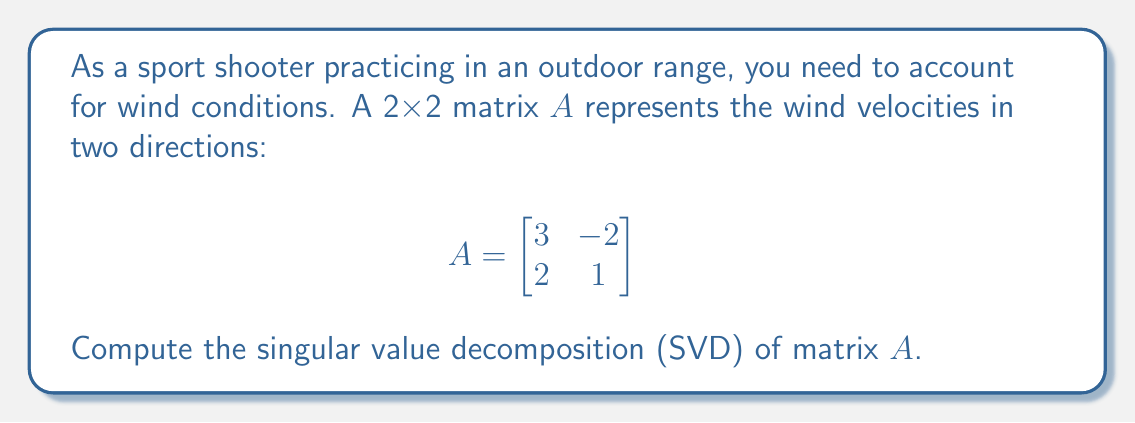Could you help me with this problem? To find the singular value decomposition of matrix $A$, we need to find matrices $U$, $\Sigma$, and $V^T$ such that $A = U\Sigma V^T$. Let's follow these steps:

1) First, calculate $A^TA$:
   $$A^TA = \begin{bmatrix}
   3 & 2 \\
   -2 & 1
   \end{bmatrix} \begin{bmatrix}
   3 & -2 \\
   2 & 1
   \end{bmatrix} = \begin{bmatrix}
   13 & -4 \\
   -4 & 5
   \end{bmatrix}$$

2) Find the eigenvalues of $A^TA$:
   $det(A^TA - \lambda I) = \begin{vmatrix}
   13-\lambda & -4 \\
   -4 & 5-\lambda
   \end{vmatrix} = (13-\lambda)(5-\lambda) - 16 = \lambda^2 - 18\lambda + 49 = 0$
   
   Solving this quadratic equation: $\lambda_1 = 16$ and $\lambda_2 = 2$

3) The singular values are the square roots of these eigenvalues:
   $\sigma_1 = \sqrt{16} = 4$ and $\sigma_2 = \sqrt{2} \approx 1.414$

4) Find the eigenvectors of $A^TA$ to get $V$:
   For $\lambda_1 = 16$: $(A^TA - 16I)v_1 = 0$
   $\begin{bmatrix}
   -3 & -4 \\
   -4 & -11
   \end{bmatrix} v_1 = 0$
   Solving this gives $v_1 = [\frac{4}{\sqrt{17}}, \frac{1}{\sqrt{17}}]^T$
   
   For $\lambda_2 = 2$: $(A^TA - 2I)v_2 = 0$
   $\begin{bmatrix}
   11 & -4 \\
   -4 & 3
   \end{bmatrix} v_2 = 0$
   Solving this gives $v_2 = [\frac{1}{\sqrt{17}}, -\frac{4}{\sqrt{17}}]^T$

   Therefore, $V = [\frac{4}{\sqrt{17}}, \frac{1}{\sqrt{17}}; \frac{1}{\sqrt{17}}, -\frac{4}{\sqrt{17}}]$

5) Calculate $U$ using $U = AV\Sigma^{-1}$:
   $U = \frac{1}{4\sqrt{17}}[12+2\sqrt{2}, 3-8\sqrt{2}; 8+3\sqrt{2}, -12+2\sqrt{2}]$

6) The singular value decomposition is:
   $$A = U\Sigma V^T = \frac{1}{4\sqrt{17}}
   \begin{bmatrix}
   12+2\sqrt{2} & 3-8\sqrt{2} \\
   8+3\sqrt{2} & -12+2\sqrt{2}
   \end{bmatrix}
   \begin{bmatrix}
   4 & 0 \\
   0 & \sqrt{2}
   \end{bmatrix}
   \begin{bmatrix}
   \frac{4}{\sqrt{17}} & \frac{1}{\sqrt{17}} \\
   \frac{1}{\sqrt{17}} & -\frac{4}{\sqrt{17}}
   \end{bmatrix}$$
Answer: $A = U\Sigma V^T$ where
$U = \frac{1}{4\sqrt{17}}[12+2\sqrt{2}, 3-8\sqrt{2}; 8+3\sqrt{2}, -12+2\sqrt{2}]$,
$\Sigma = diag(4, \sqrt{2})$,
$V^T = [\frac{4}{\sqrt{17}}, \frac{1}{\sqrt{17}}; \frac{1}{\sqrt{17}}, -\frac{4}{\sqrt{17}}]$ 